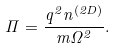<formula> <loc_0><loc_0><loc_500><loc_500>\Pi = \frac { q ^ { 2 } n ^ { ( 2 D ) } } { m \Omega ^ { 2 } } .</formula> 